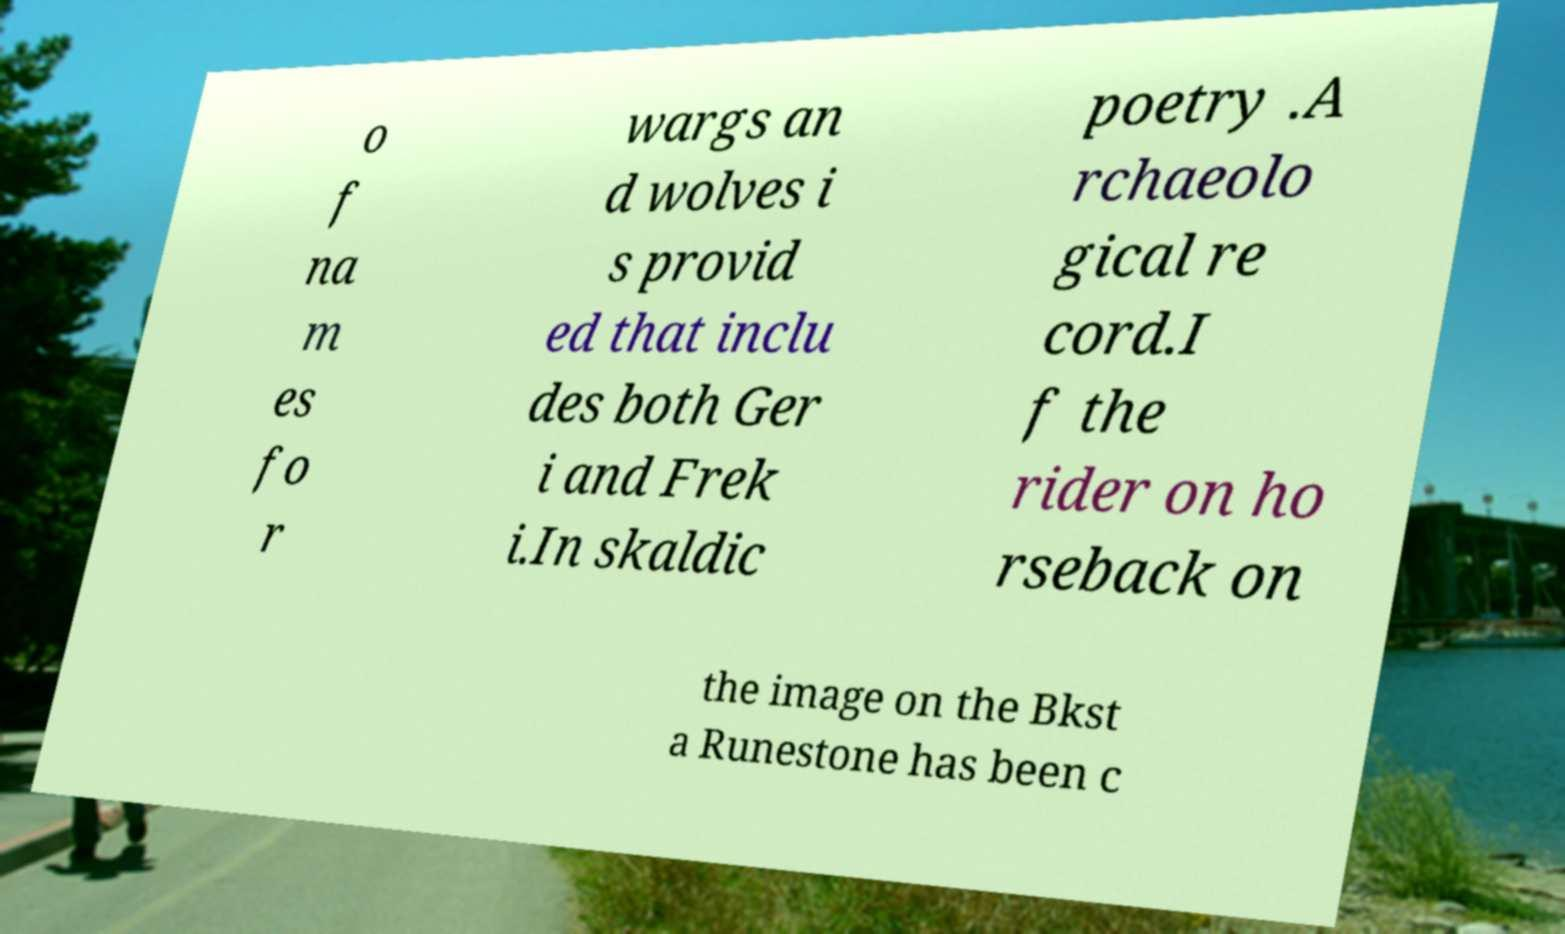What messages or text are displayed in this image? I need them in a readable, typed format. o f na m es fo r wargs an d wolves i s provid ed that inclu des both Ger i and Frek i.In skaldic poetry .A rchaeolo gical re cord.I f the rider on ho rseback on the image on the Bkst a Runestone has been c 